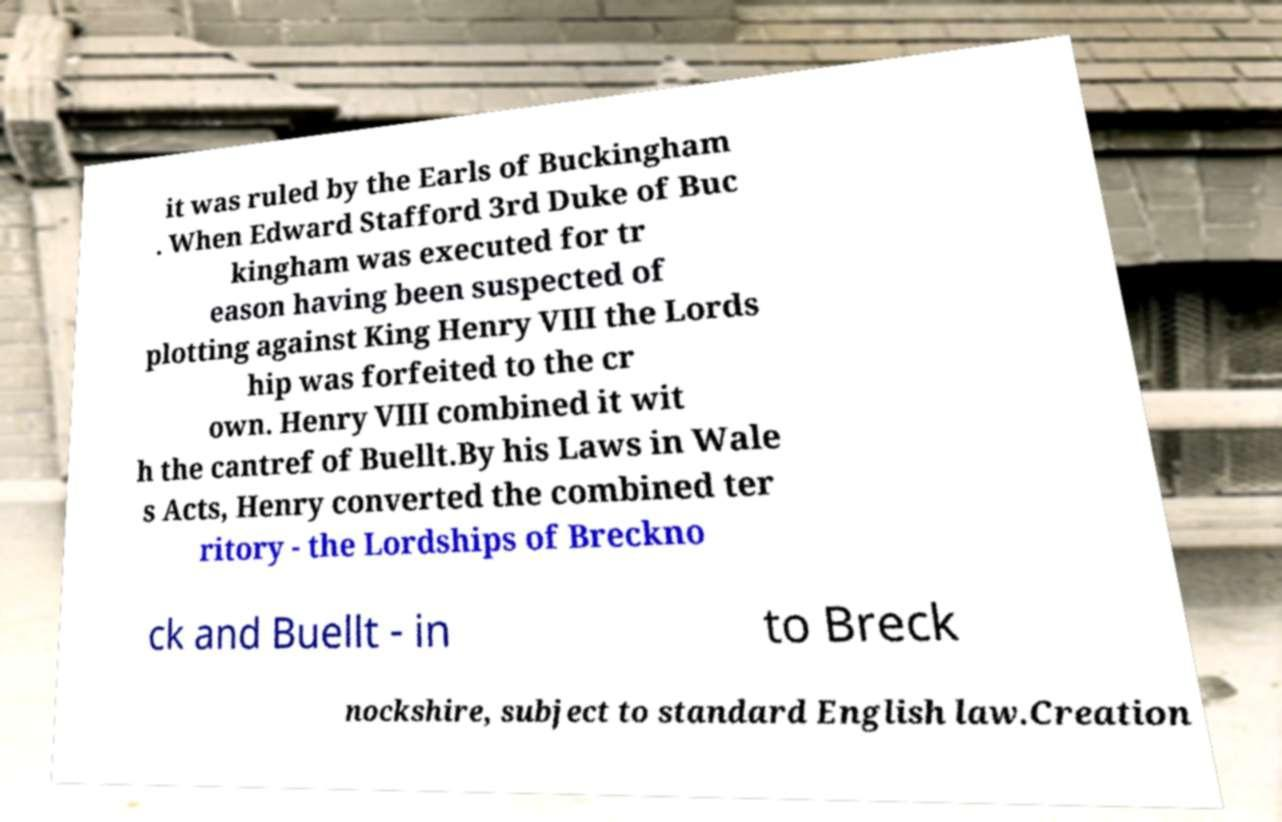Can you read and provide the text displayed in the image?This photo seems to have some interesting text. Can you extract and type it out for me? it was ruled by the Earls of Buckingham . When Edward Stafford 3rd Duke of Buc kingham was executed for tr eason having been suspected of plotting against King Henry VIII the Lords hip was forfeited to the cr own. Henry VIII combined it wit h the cantref of Buellt.By his Laws in Wale s Acts, Henry converted the combined ter ritory - the Lordships of Breckno ck and Buellt - in to Breck nockshire, subject to standard English law.Creation 